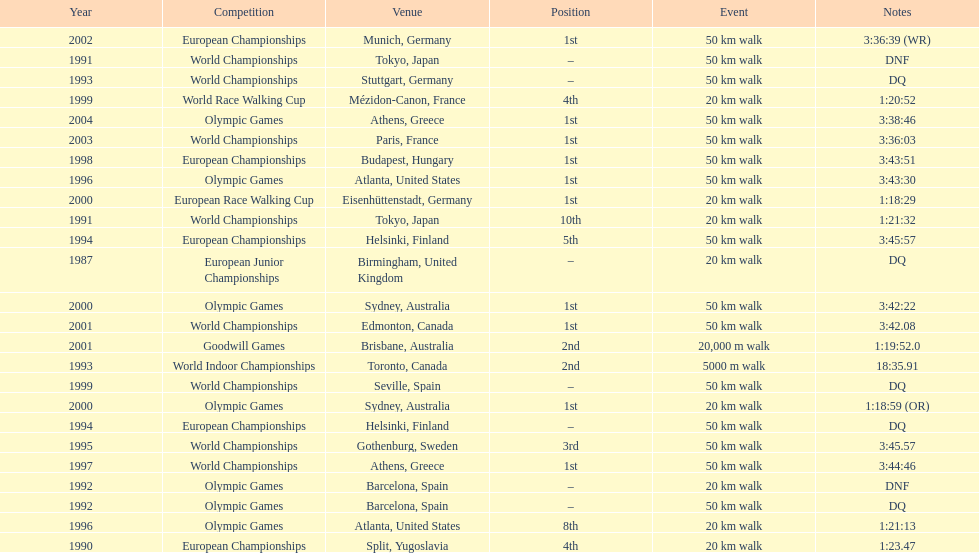Which venue is listed the most? Athens, Greece. 